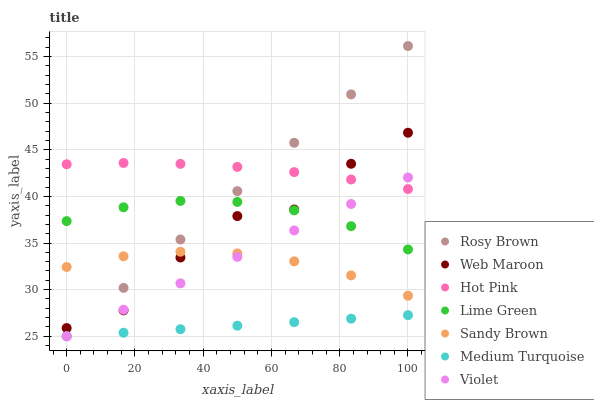Does Medium Turquoise have the minimum area under the curve?
Answer yes or no. Yes. Does Hot Pink have the maximum area under the curve?
Answer yes or no. Yes. Does Sandy Brown have the minimum area under the curve?
Answer yes or no. No. Does Sandy Brown have the maximum area under the curve?
Answer yes or no. No. Is Medium Turquoise the smoothest?
Answer yes or no. Yes. Is Web Maroon the roughest?
Answer yes or no. Yes. Is Sandy Brown the smoothest?
Answer yes or no. No. Is Sandy Brown the roughest?
Answer yes or no. No. Does Rosy Brown have the lowest value?
Answer yes or no. Yes. Does Sandy Brown have the lowest value?
Answer yes or no. No. Does Rosy Brown have the highest value?
Answer yes or no. Yes. Does Sandy Brown have the highest value?
Answer yes or no. No. Is Medium Turquoise less than Web Maroon?
Answer yes or no. Yes. Is Hot Pink greater than Medium Turquoise?
Answer yes or no. Yes. Does Violet intersect Web Maroon?
Answer yes or no. Yes. Is Violet less than Web Maroon?
Answer yes or no. No. Is Violet greater than Web Maroon?
Answer yes or no. No. Does Medium Turquoise intersect Web Maroon?
Answer yes or no. No. 